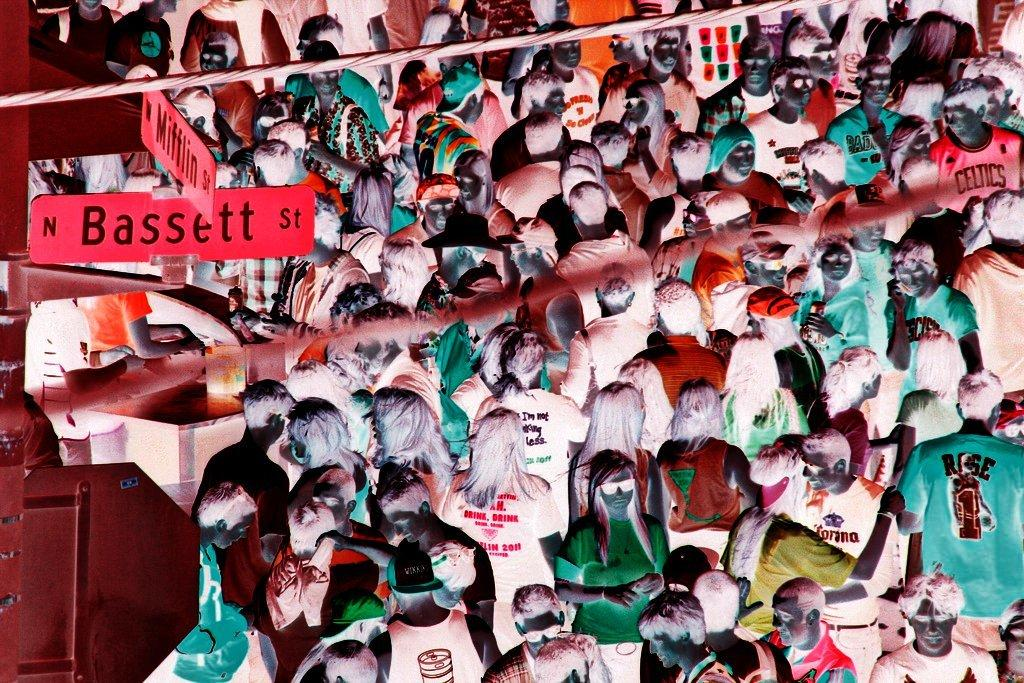Provide a one-sentence caption for the provided image. A large crowd gathers at the corner of North Bassett Street. 